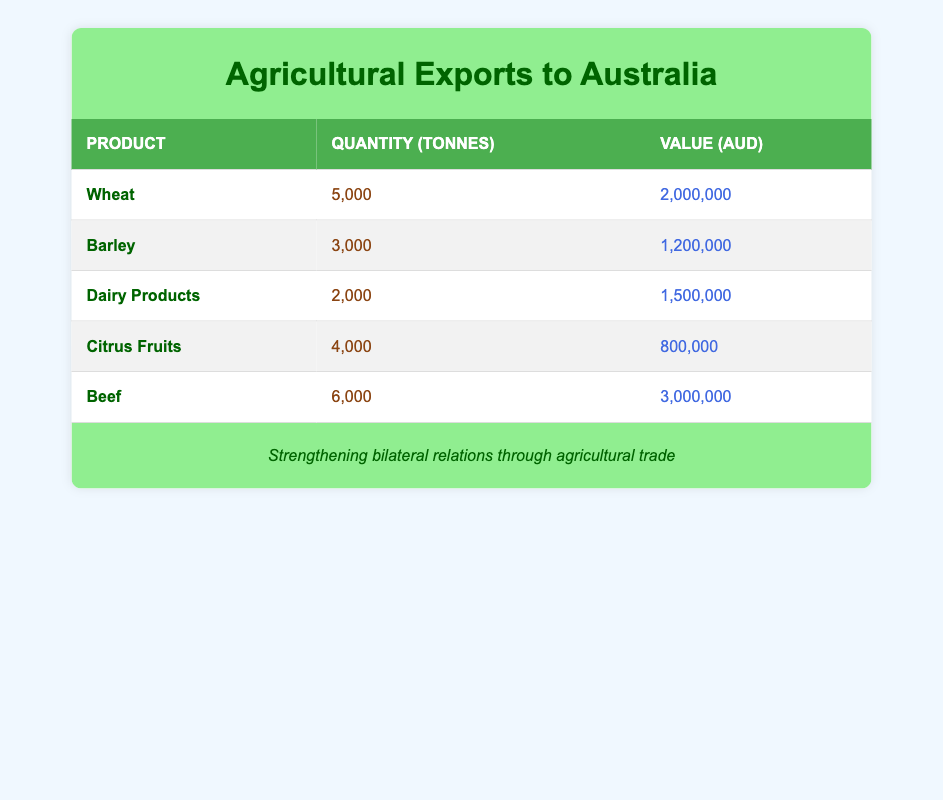What is the total quantity of beef exported to Australia? The table states that the quantity of beef exported is 6,000 tonnes, so the total quantity is simply the value noted.
Answer: 6,000 tonnes Which agricultural product has the highest export value? The table shows that beef has the highest export value of 3,000,000 AUD, which is greater than the values for the other products.
Answer: Beef What is the average export value of agricultural products listed in the table? To find the average, first add all the export values: 2,000,000 + 1,200,000 + 1,500,000 + 800,000 + 3,000,000 = 8,500,000 AUD. There are 5 products, so the average is 8,500,000 / 5 = 1,700,000 AUD.
Answer: 1,700,000 AUD Is the export value of citrus fruits greater than the export value of barley? The table shows that the value of citrus fruits is 800,000 AUD while barley has an export value of 1,200,000 AUD. Since 800,000 is less than 1,200,000, the statement is false.
Answer: No What is the total quantity of all agricultural exports combined? By summing the quantities: 5,000 (Wheat) + 3,000 (Barley) + 2,000 (Dairy Products) + 4,000 (Citrus Fruits) + 6,000 (Beef) = 20,000 tonnes. This represents the total quantity of exports to Australia.
Answer: 20,000 tonnes 